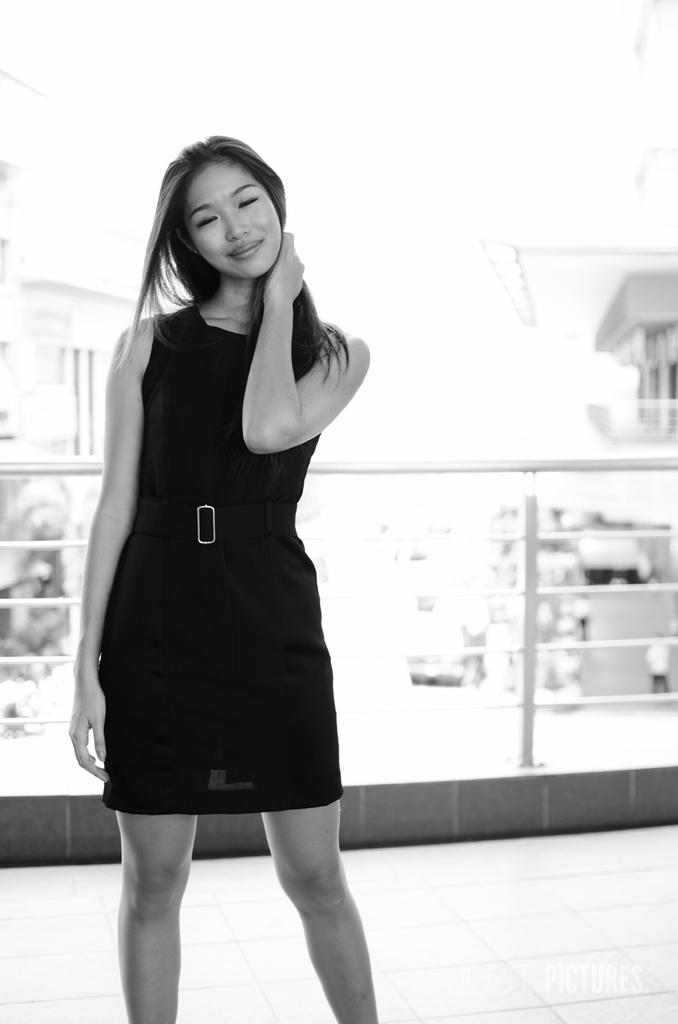Who is present in the image? There is a woman in the image. What is the woman wearing? The woman is wearing a dress. What is the woman's facial expression? The woman is smiling. What is the woman standing on? The woman is standing on a floor. What can be seen in the background of the image? There is a fence and buildings in the background of the image. What is the color of the background? The background color is white. Can you see a kitten playing on the ship in the background of the image? There is no kitten or ship present in the image; it features a woman standing in front of a fence and buildings. 